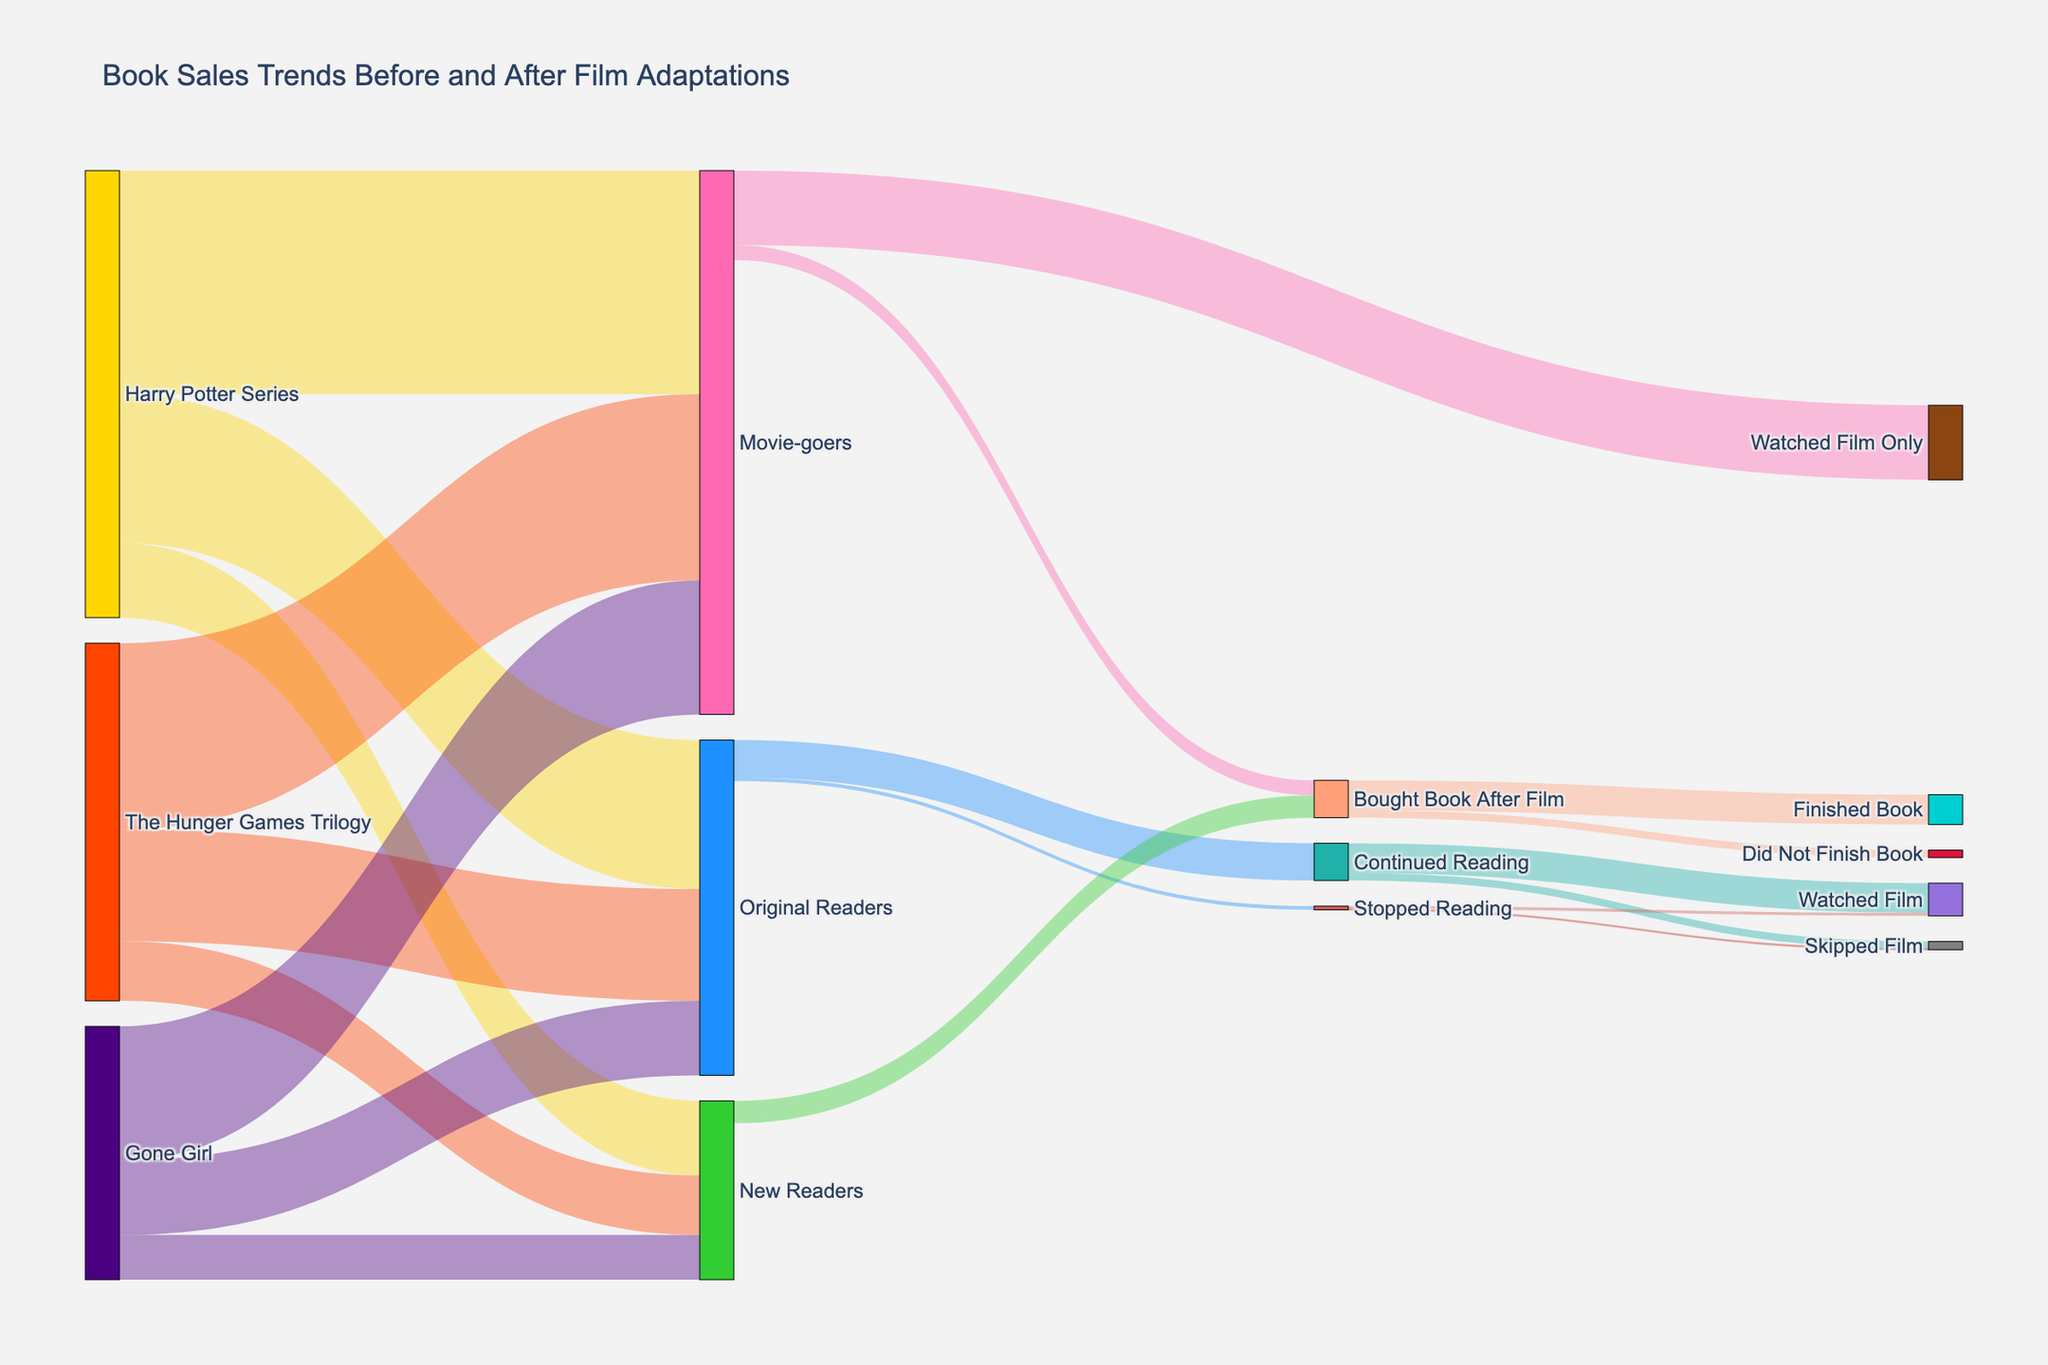What's the title of the Sankey Diagram? The title is usually displayed prominently at the top of a plot. In this case, the title is given in the layout specifications.
Answer: Book Sales Trends Before and After Film Adaptations What segment of readers showed the highest value moving to "Watched Film Only"? To find this, locate the "Watched Film Only" node and trace the largest flow leading into it. This stream originates from "Movie-goers" with a value of 1,000,000.
Answer: Movie-goers with a value of 1,000,000 How many people bought the book after watching the film? Look for flows leading to "Bought Book After Film." Sum the relevant flows: New Readers (300,000) and Movie-goers (200,000). Total is 300,000 + 200,000 = 500,000.
Answer: 500,000 Which series had the largest number of original readers? Compare the values linked to the "Original Readers" for each series. Harry Potter Series has the highest with 2,000,000.
Answer: Harry Potter Series with 2,000,000 Among those who continued reading, how many watched the film? Locate the flow from "Continued Reading" to "Watched Film." The value for this flow is 400,000.
Answer: 400,000 How many new readers did "The Hunger Games Trilogy" attract? Find the value attached to "New Readers" for "The Hunger Games Trilogy." It is 800,000.
Answer: 800,000 What percent of original readers continued reading? Consider the flow from "Original Readers" to "Continued Reading" and calculate the percentage: (500,000 / (500,000 + 50,000)) * 100 = 90.91%.
Answer: 90.91% How many people finished the book after buying it post-film? Look for the flow from "Bought Book After Film" to "Finished Book." The number is 400,000.
Answer: 400,000 For "Gone Girl," how many movie-goers were there compared to original readers? Locate the values for "Gone Girl" under "Movie-goers" (1,800,000) and "Original Readers" (1,000,000). Compare: 1,800,000 vs. 1,000,000.
Answer: 1,800,000 vs 1,000,000 Which type of reader had the least number moving to "Skipped Film"? Compare the values leading into "Skipped Film." "Stopped Reading" has the least with 10,000.
Answer: Stopped Reading with 10,000 